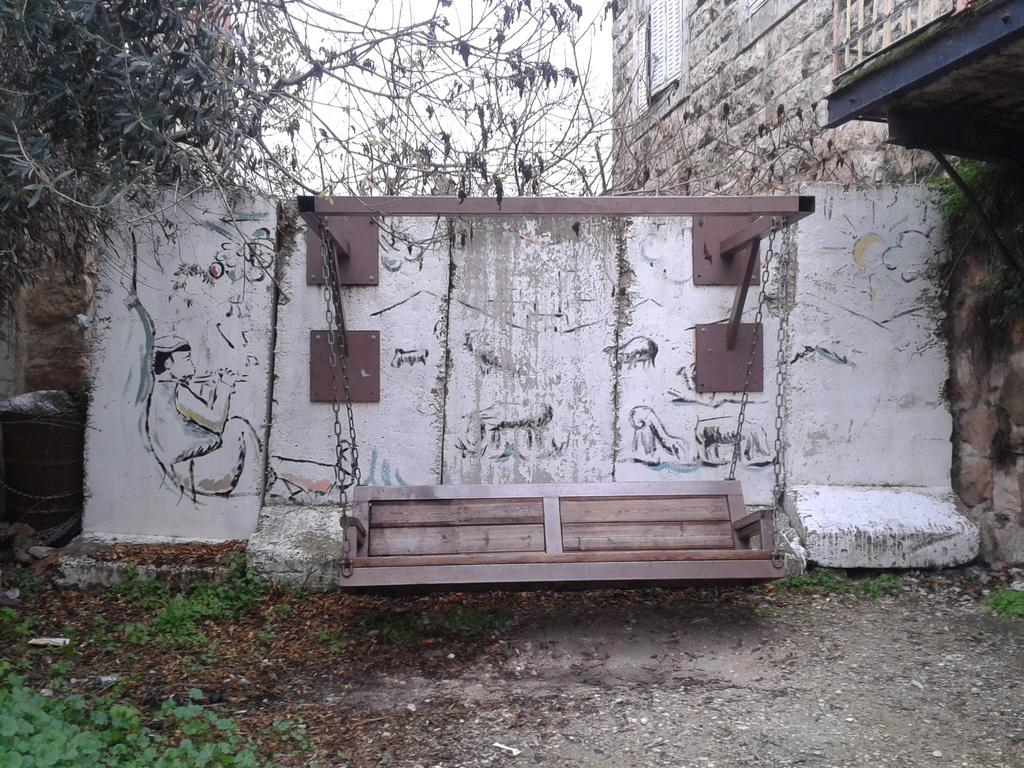What type of furniture is hanging in the picture? There is a hanging bench in the picture. What is the background of the picture? There is a wall visible in the picture. What type of vegetation can be seen in the picture? There are trees in the picture. What type of cabbage is being used to form a pattern on the hanging bench? There is no cabbage present in the image, nor is there any pattern on the hanging bench. 